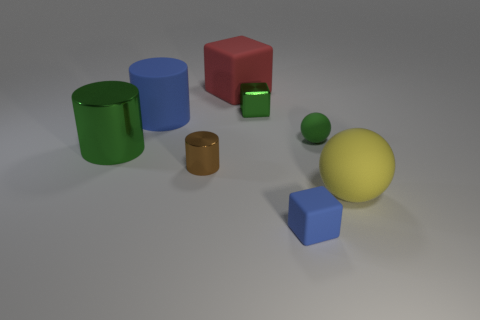There is a tiny ball that is the same color as the shiny block; what is it made of?
Keep it short and to the point. Rubber. There is a small ball; does it have the same color as the tiny cube that is behind the large yellow thing?
Your answer should be compact. Yes. What material is the yellow thing that is the same shape as the small green matte thing?
Offer a terse response. Rubber. Do the big metal cylinder and the big block have the same color?
Ensure brevity in your answer.  No. Does the yellow object in front of the shiny cube have the same size as the small brown metallic thing?
Provide a succinct answer. No. How big is the object that is both to the left of the big rubber cube and behind the large metal cylinder?
Provide a short and direct response. Large. Does the cylinder behind the big green metallic cylinder have the same color as the tiny matte block?
Your answer should be very brief. Yes. There is a small object that is both right of the small green shiny cube and in front of the green sphere; what is its shape?
Your response must be concise. Cube. Is there a big object of the same color as the metallic cube?
Provide a short and direct response. Yes. There is a rubber block on the left side of the tiny cube in front of the tiny brown metallic cylinder; what color is it?
Your answer should be very brief. Red. 